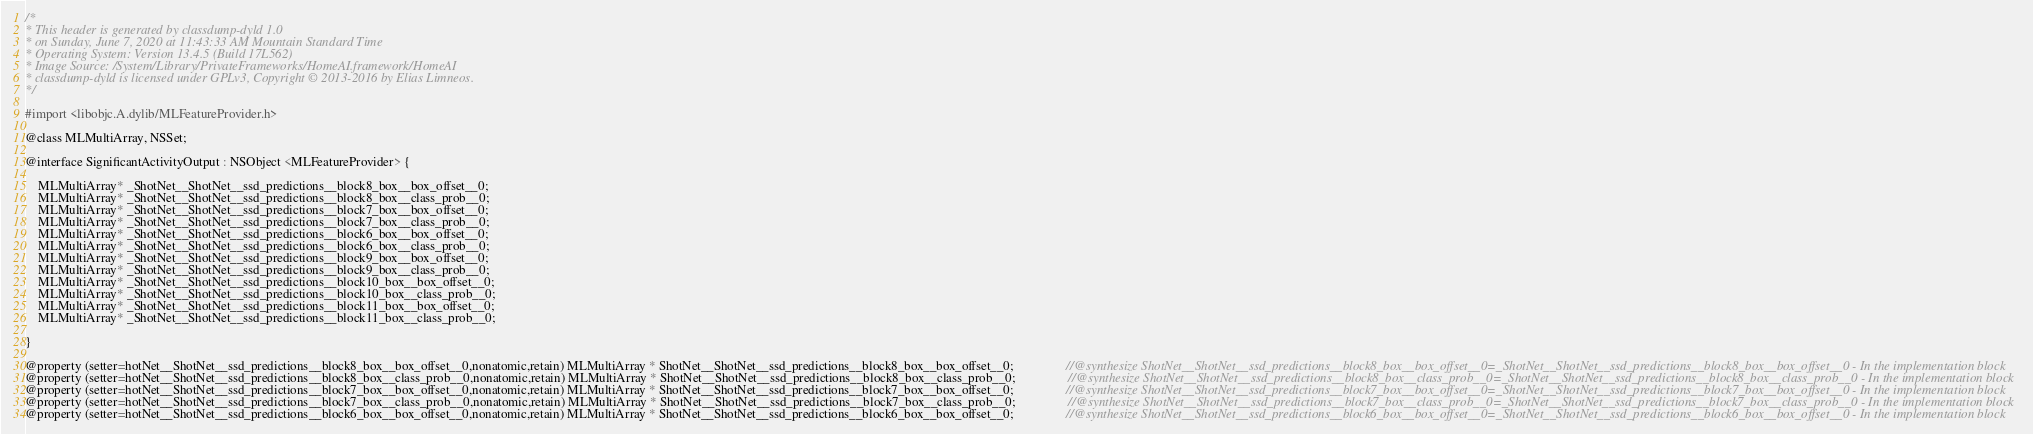Convert code to text. <code><loc_0><loc_0><loc_500><loc_500><_C_>/*
* This header is generated by classdump-dyld 1.0
* on Sunday, June 7, 2020 at 11:43:33 AM Mountain Standard Time
* Operating System: Version 13.4.5 (Build 17L562)
* Image Source: /System/Library/PrivateFrameworks/HomeAI.framework/HomeAI
* classdump-dyld is licensed under GPLv3, Copyright © 2013-2016 by Elias Limneos.
*/

#import <libobjc.A.dylib/MLFeatureProvider.h>

@class MLMultiArray, NSSet;

@interface SignificantActivityOutput : NSObject <MLFeatureProvider> {

	MLMultiArray* _ShotNet__ShotNet__ssd_predictions__block8_box__box_offset__0;
	MLMultiArray* _ShotNet__ShotNet__ssd_predictions__block8_box__class_prob__0;
	MLMultiArray* _ShotNet__ShotNet__ssd_predictions__block7_box__box_offset__0;
	MLMultiArray* _ShotNet__ShotNet__ssd_predictions__block7_box__class_prob__0;
	MLMultiArray* _ShotNet__ShotNet__ssd_predictions__block6_box__box_offset__0;
	MLMultiArray* _ShotNet__ShotNet__ssd_predictions__block6_box__class_prob__0;
	MLMultiArray* _ShotNet__ShotNet__ssd_predictions__block9_box__box_offset__0;
	MLMultiArray* _ShotNet__ShotNet__ssd_predictions__block9_box__class_prob__0;
	MLMultiArray* _ShotNet__ShotNet__ssd_predictions__block10_box__box_offset__0;
	MLMultiArray* _ShotNet__ShotNet__ssd_predictions__block10_box__class_prob__0;
	MLMultiArray* _ShotNet__ShotNet__ssd_predictions__block11_box__box_offset__0;
	MLMultiArray* _ShotNet__ShotNet__ssd_predictions__block11_box__class_prob__0;

}

@property (setter=hotNet__ShotNet__ssd_predictions__block8_box__box_offset__0,nonatomic,retain) MLMultiArray * ShotNet__ShotNet__ssd_predictions__block8_box__box_offset__0;                //@synthesize ShotNet__ShotNet__ssd_predictions__block8_box__box_offset__0=_ShotNet__ShotNet__ssd_predictions__block8_box__box_offset__0 - In the implementation block
@property (setter=hotNet__ShotNet__ssd_predictions__block8_box__class_prob__0,nonatomic,retain) MLMultiArray * ShotNet__ShotNet__ssd_predictions__block8_box__class_prob__0;                //@synthesize ShotNet__ShotNet__ssd_predictions__block8_box__class_prob__0=_ShotNet__ShotNet__ssd_predictions__block8_box__class_prob__0 - In the implementation block
@property (setter=hotNet__ShotNet__ssd_predictions__block7_box__box_offset__0,nonatomic,retain) MLMultiArray * ShotNet__ShotNet__ssd_predictions__block7_box__box_offset__0;                //@synthesize ShotNet__ShotNet__ssd_predictions__block7_box__box_offset__0=_ShotNet__ShotNet__ssd_predictions__block7_box__box_offset__0 - In the implementation block
@property (setter=hotNet__ShotNet__ssd_predictions__block7_box__class_prob__0,nonatomic,retain) MLMultiArray * ShotNet__ShotNet__ssd_predictions__block7_box__class_prob__0;                //@synthesize ShotNet__ShotNet__ssd_predictions__block7_box__class_prob__0=_ShotNet__ShotNet__ssd_predictions__block7_box__class_prob__0 - In the implementation block
@property (setter=hotNet__ShotNet__ssd_predictions__block6_box__box_offset__0,nonatomic,retain) MLMultiArray * ShotNet__ShotNet__ssd_predictions__block6_box__box_offset__0;                //@synthesize ShotNet__ShotNet__ssd_predictions__block6_box__box_offset__0=_ShotNet__ShotNet__ssd_predictions__block6_box__box_offset__0 - In the implementation block</code> 